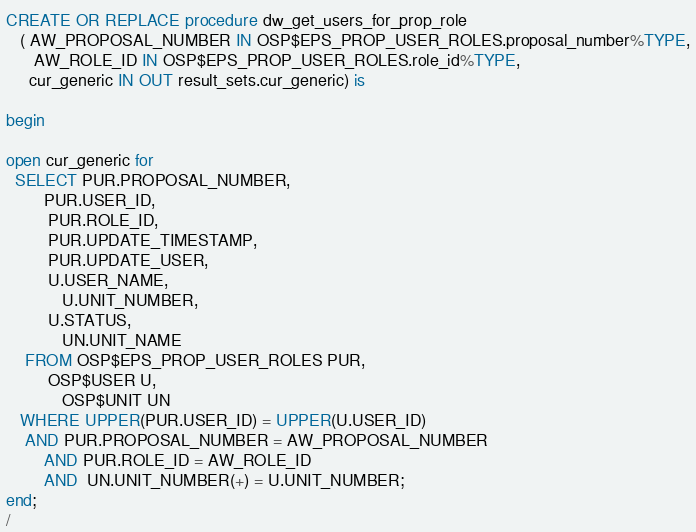Convert code to text. <code><loc_0><loc_0><loc_500><loc_500><_SQL_>CREATE OR REPLACE procedure dw_get_users_for_prop_role
   ( AW_PROPOSAL_NUMBER IN OSP$EPS_PROP_USER_ROLES.proposal_number%TYPE,
	  AW_ROLE_ID IN OSP$EPS_PROP_USER_ROLES.role_id%TYPE,
     cur_generic IN OUT result_sets.cur_generic) is

begin

open cur_generic for
  SELECT PUR.PROPOSAL_NUMBER,
   		PUR.USER_ID,
         PUR.ROLE_ID,
         PUR.UPDATE_TIMESTAMP,
         PUR.UPDATE_USER,
         U.USER_NAME,
			U.UNIT_NUMBER,
         U.STATUS,
			UN.UNIT_NAME
    FROM OSP$EPS_PROP_USER_ROLES PUR,
         OSP$USER U,
			OSP$UNIT UN
   WHERE UPPER(PUR.USER_ID) = UPPER(U.USER_ID)
   	AND PUR.PROPOSAL_NUMBER = AW_PROPOSAL_NUMBER
     	AND PUR.ROLE_ID = AW_ROLE_ID
		AND  UN.UNIT_NUMBER(+) = U.UNIT_NUMBER;
end;
/

</code> 